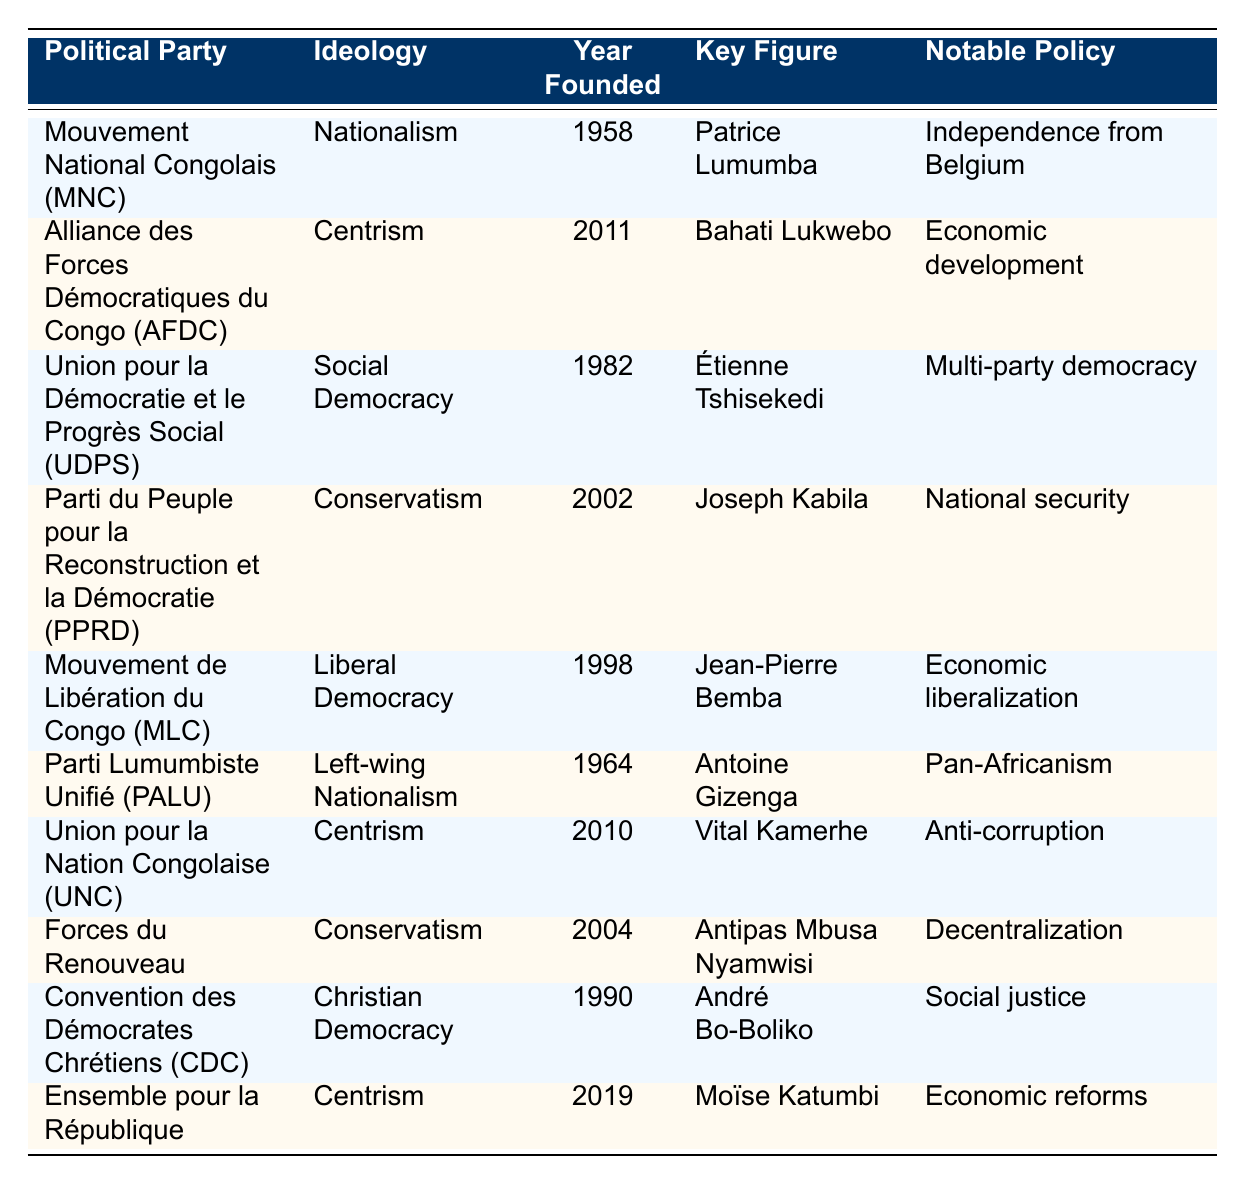What is the ideology of the Mouvement National Congolais (MNC)? The table lists the ideology for the MNC as Nationalism.
Answer: Nationalism Who was the key figure in the Union pour la Démocratie et le Progrès Social (UDPS)? The key figure for the UDPS is Étienne Tshisekedi as per the table.
Answer: Étienne Tshisekedi Which political party was founded most recently? The most recently founded party in the table is Ensemble pour la République, established in 2019.
Answer: Ensemble pour la République What notable policy is associated with the Parti du Peuple pour la Reconstruction et la Démocratie (PPRD)? According to the table, the notable policy is National security.
Answer: National security How many parties have a centrist ideology? The table shows three parties with a centrist ideology: AFDC, UNC, and Ensemble pour la République.
Answer: 3 Is the Mouvement de Libération du Congo (MLC) associated with social democracy? The table indicates that the MLC is aligned with Liberal Democracy, not social democracy, making the statement false.
Answer: False What is the year founded for the Parti Lumumbiste Unifié (PALU) and what is its notable policy? The PALU was founded in 1964, and its notable policy is Pan-Africanism, as stated in the table.
Answer: 1964, Pan-Africanism Compare the ideologies of the Parti du Peuple pour la Reconstruction et la Démocratie (PPRD) and the Forces du Renouveau. The PPRD follows Conservatism, while the Forces du Renouveau also has a Conservatism ideology, indicating they share the same ideology.
Answer: Same ideology (Conservatism) Which ideology has the most political parties associated with it according to the table? The table shows that Centrism has the most parties associated with it (3), which are AFDC, UNC, and Ensemble pour la République.
Answer: Centrism If you summed the years founded of the parties on the left of the table, what would that total be? The sum of founding years for MNC (1958), PALU (1964), UDPS (1982), and MLC (1998) is 1958 + 1964 + 1982 + 1998 = 7902.
Answer: 7902 